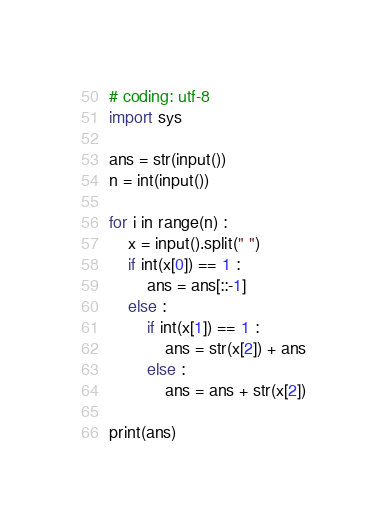<code> <loc_0><loc_0><loc_500><loc_500><_Python_># coding: utf-8
import sys

ans = str(input())
n = int(input())

for i in range(n) :
    x = input().split(" ")
    if int(x[0]) == 1 :
        ans = ans[::-1]
    else :
        if int(x[1]) == 1 :
            ans = str(x[2]) + ans
        else :
            ans = ans + str(x[2])

print(ans)</code> 